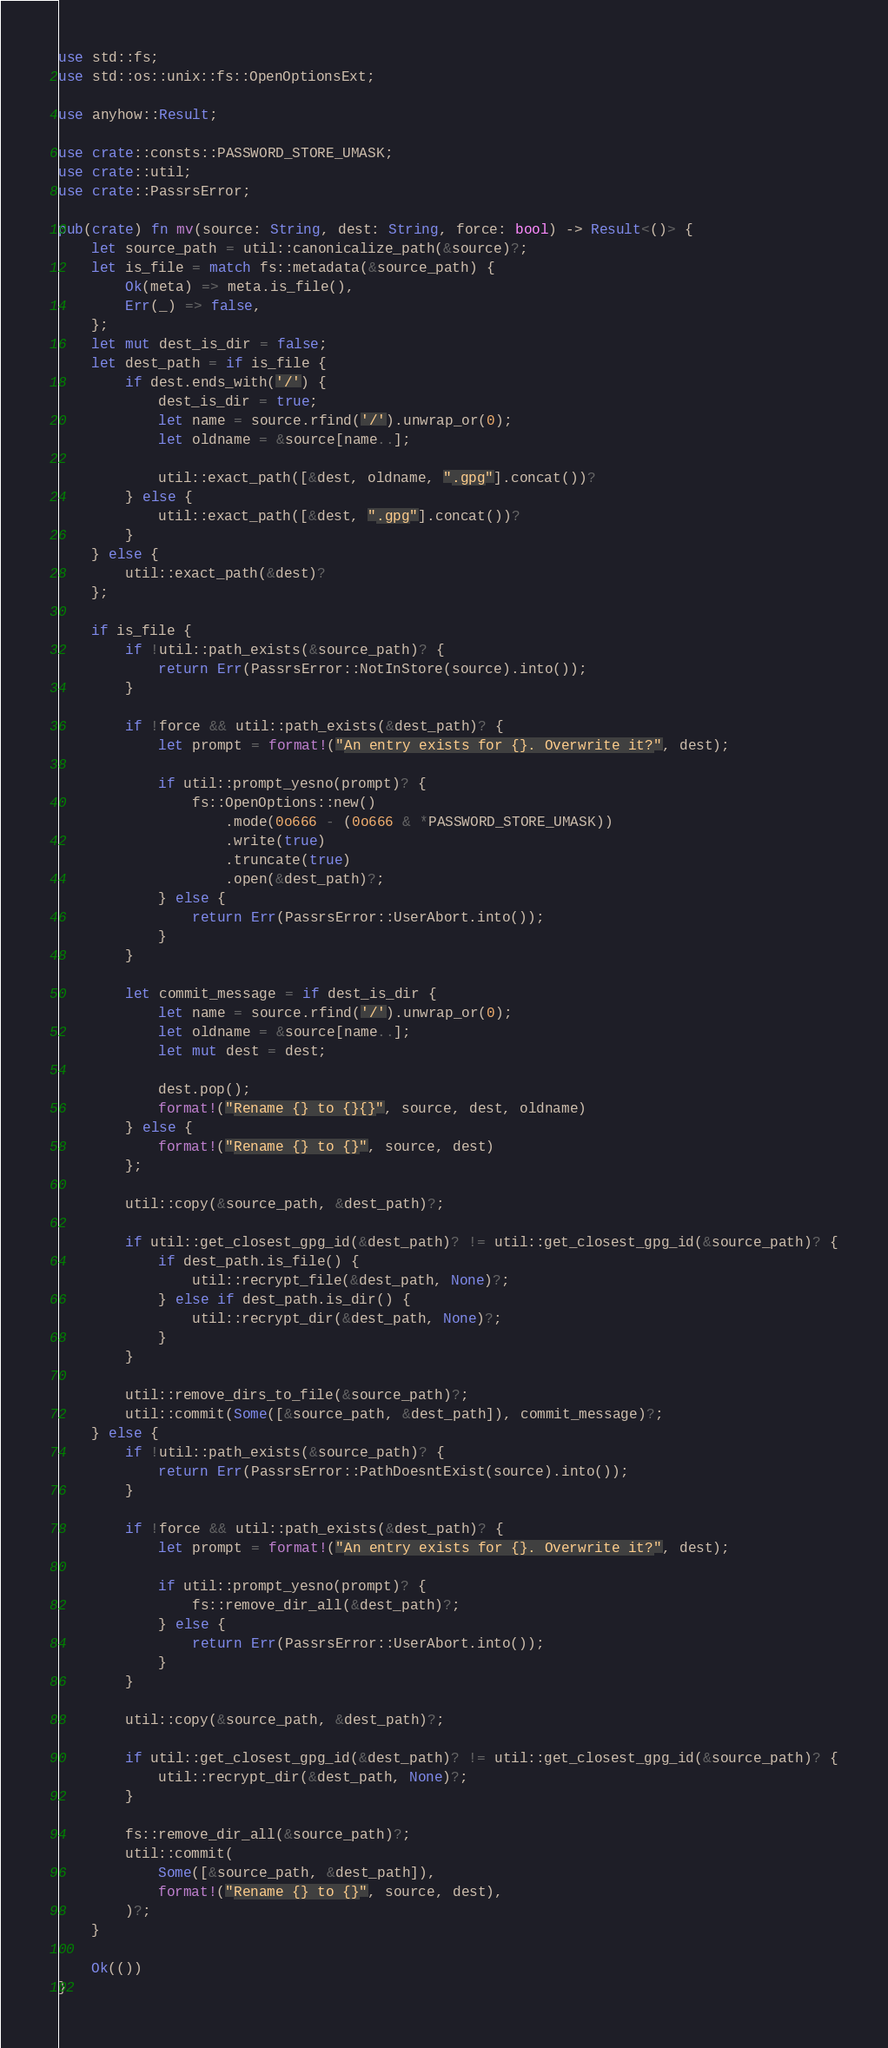Convert code to text. <code><loc_0><loc_0><loc_500><loc_500><_Rust_>use std::fs;
use std::os::unix::fs::OpenOptionsExt;

use anyhow::Result;

use crate::consts::PASSWORD_STORE_UMASK;
use crate::util;
use crate::PassrsError;

pub(crate) fn mv(source: String, dest: String, force: bool) -> Result<()> {
    let source_path = util::canonicalize_path(&source)?;
    let is_file = match fs::metadata(&source_path) {
        Ok(meta) => meta.is_file(),
        Err(_) => false,
    };
    let mut dest_is_dir = false;
    let dest_path = if is_file {
        if dest.ends_with('/') {
            dest_is_dir = true;
            let name = source.rfind('/').unwrap_or(0);
            let oldname = &source[name..];

            util::exact_path([&dest, oldname, ".gpg"].concat())?
        } else {
            util::exact_path([&dest, ".gpg"].concat())?
        }
    } else {
        util::exact_path(&dest)?
    };

    if is_file {
        if !util::path_exists(&source_path)? {
            return Err(PassrsError::NotInStore(source).into());
        }

        if !force && util::path_exists(&dest_path)? {
            let prompt = format!("An entry exists for {}. Overwrite it?", dest);

            if util::prompt_yesno(prompt)? {
                fs::OpenOptions::new()
                    .mode(0o666 - (0o666 & *PASSWORD_STORE_UMASK))
                    .write(true)
                    .truncate(true)
                    .open(&dest_path)?;
            } else {
                return Err(PassrsError::UserAbort.into());
            }
        }

        let commit_message = if dest_is_dir {
            let name = source.rfind('/').unwrap_or(0);
            let oldname = &source[name..];
            let mut dest = dest;

            dest.pop();
            format!("Rename {} to {}{}", source, dest, oldname)
        } else {
            format!("Rename {} to {}", source, dest)
        };

        util::copy(&source_path, &dest_path)?;

        if util::get_closest_gpg_id(&dest_path)? != util::get_closest_gpg_id(&source_path)? {
            if dest_path.is_file() {
                util::recrypt_file(&dest_path, None)?;
            } else if dest_path.is_dir() {
                util::recrypt_dir(&dest_path, None)?;
            }
        }

        util::remove_dirs_to_file(&source_path)?;
        util::commit(Some([&source_path, &dest_path]), commit_message)?;
    } else {
        if !util::path_exists(&source_path)? {
            return Err(PassrsError::PathDoesntExist(source).into());
        }

        if !force && util::path_exists(&dest_path)? {
            let prompt = format!("An entry exists for {}. Overwrite it?", dest);

            if util::prompt_yesno(prompt)? {
                fs::remove_dir_all(&dest_path)?;
            } else {
                return Err(PassrsError::UserAbort.into());
            }
        }

        util::copy(&source_path, &dest_path)?;

        if util::get_closest_gpg_id(&dest_path)? != util::get_closest_gpg_id(&source_path)? {
            util::recrypt_dir(&dest_path, None)?;
        }

        fs::remove_dir_all(&source_path)?;
        util::commit(
            Some([&source_path, &dest_path]),
            format!("Rename {} to {}", source, dest),
        )?;
    }

    Ok(())
}
</code> 